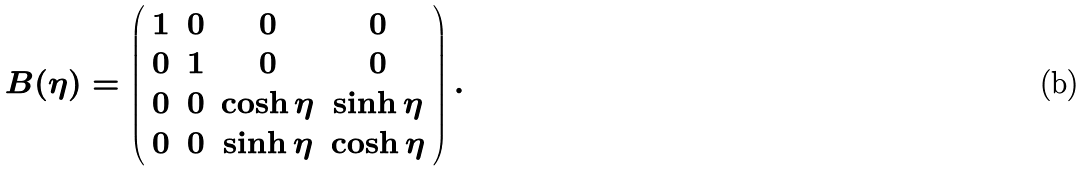Convert formula to latex. <formula><loc_0><loc_0><loc_500><loc_500>B ( \eta ) = \left ( \begin{array} { c c c c } 1 & 0 & 0 & 0 \\ 0 & 1 & 0 & 0 \\ 0 & 0 & \cosh \eta & \sinh \eta \\ 0 & 0 & \sinh \eta & \cosh \eta \end{array} \right ) .</formula> 